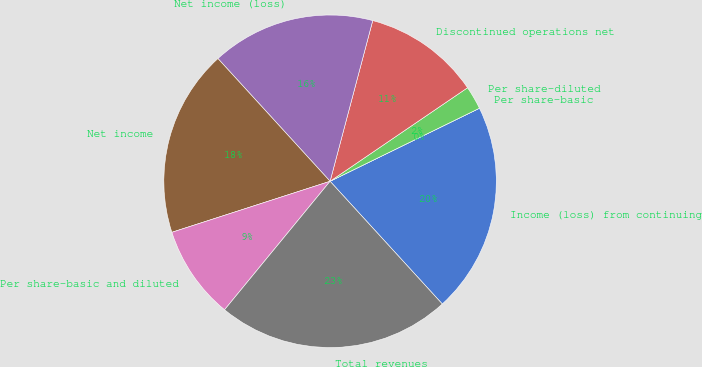Convert chart. <chart><loc_0><loc_0><loc_500><loc_500><pie_chart><fcel>Income (loss) from continuing<fcel>Per share-basic<fcel>Per share-diluted<fcel>Discontinued operations net<fcel>Net income (loss)<fcel>Net income<fcel>Per share-basic and diluted<fcel>Total revenues<nl><fcel>20.45%<fcel>0.0%<fcel>2.27%<fcel>11.36%<fcel>15.91%<fcel>18.18%<fcel>9.09%<fcel>22.73%<nl></chart> 